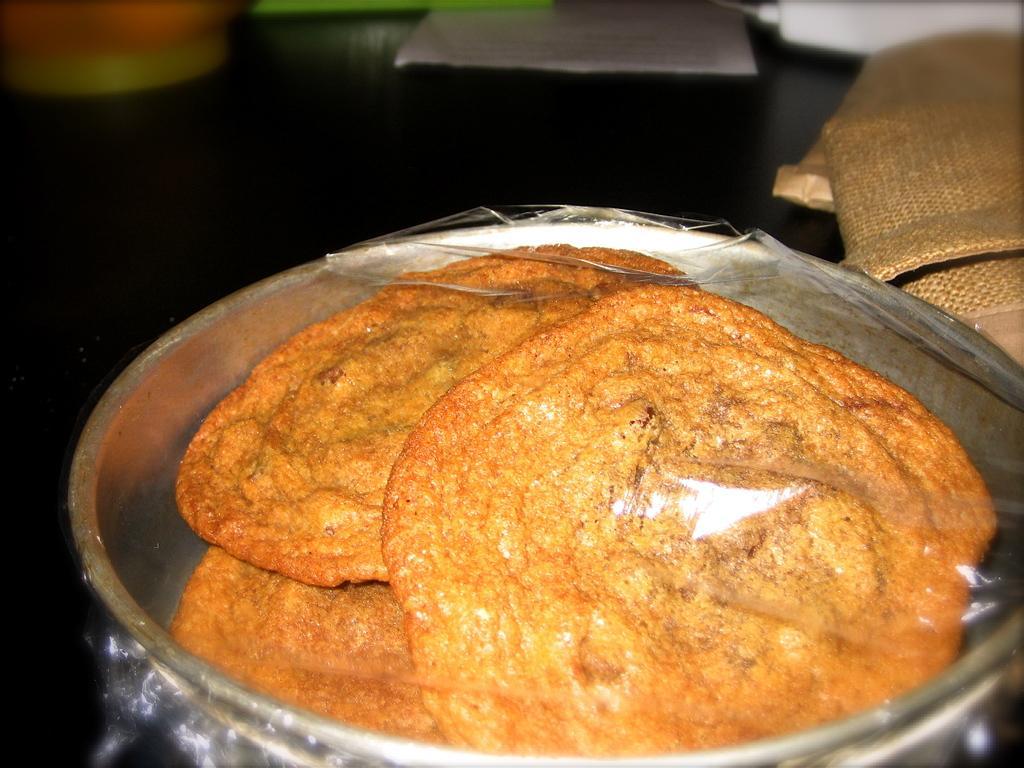Can you describe this image briefly? In this image we can see a table. On the table there are paper, polythene bag and food placed in an utensil. 